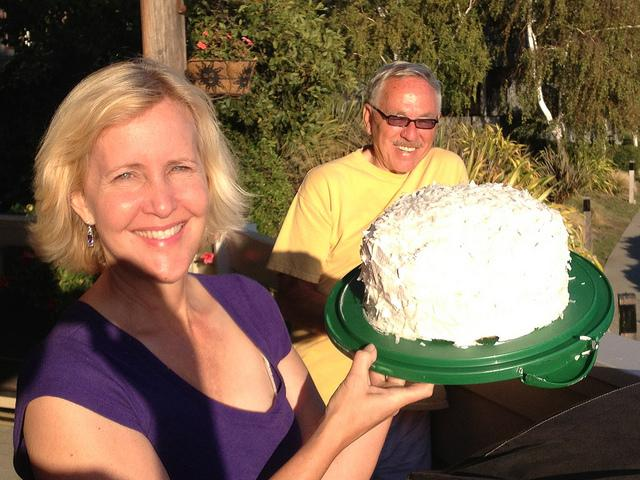The frosting is probably made from what?

Choices:
A) buttercream
B) honey
C) chocolate
D) fondant buttercream 